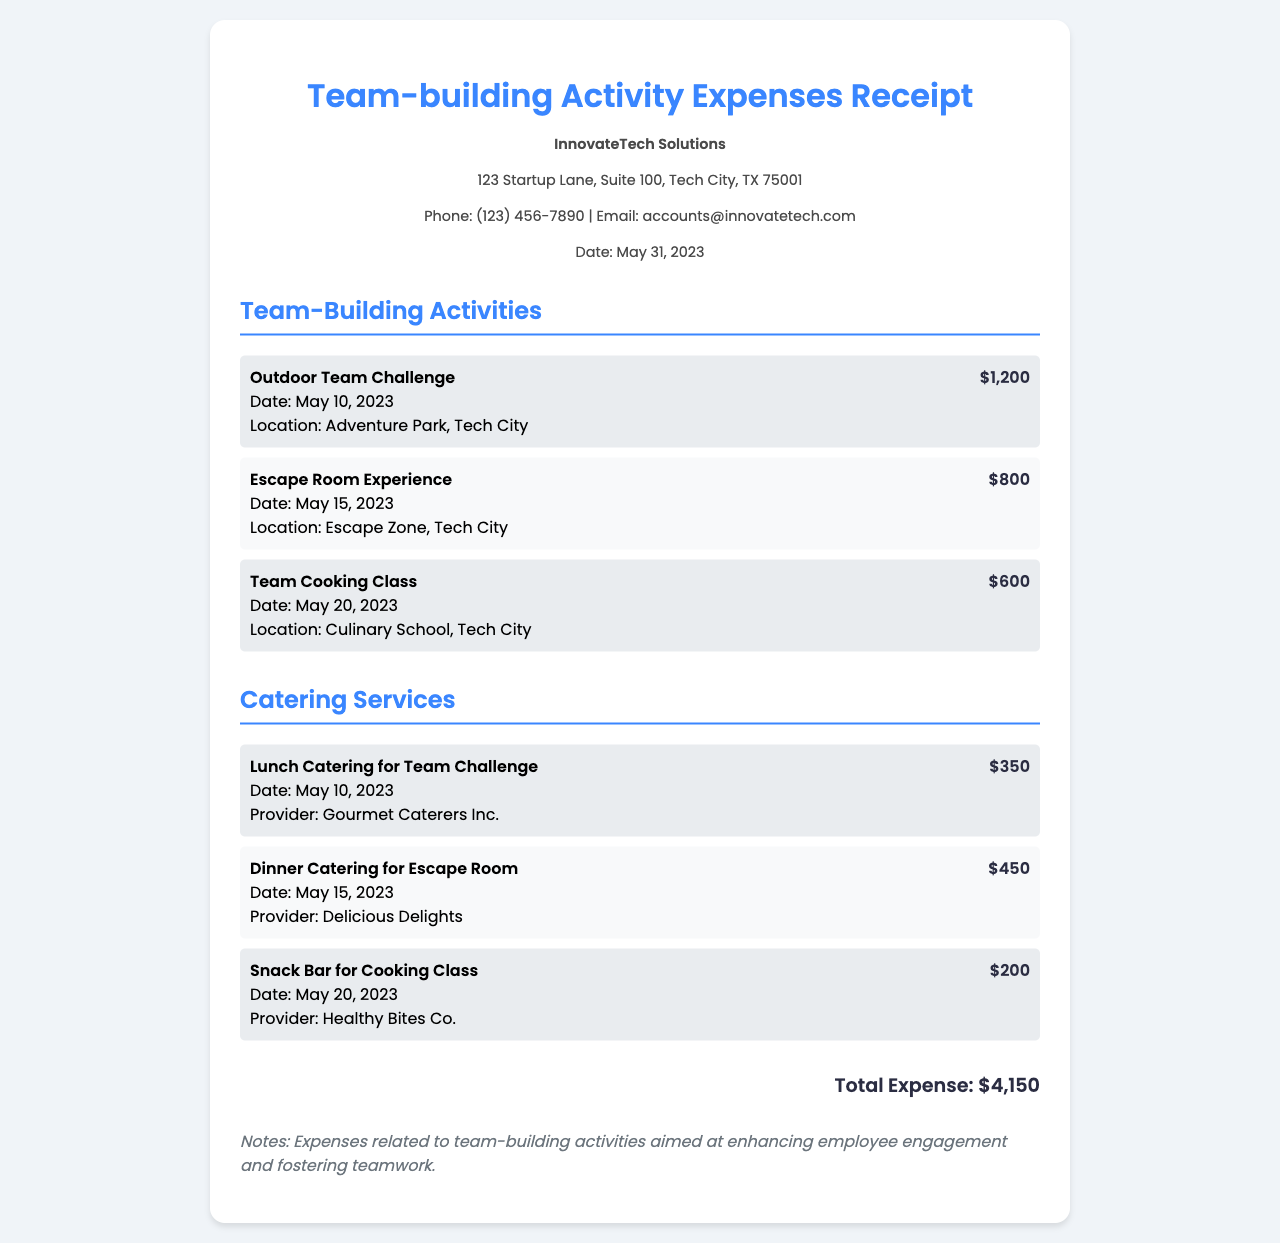What is the total expense? The total expense is listed at the bottom of the document as a sum of all activities and catering costs.
Answer: $4,150 What is the name of the company? The name of the company is stated at the top of the document.
Answer: InnovateTech Solutions When was the Outdoor Team Challenge held? The date for the Outdoor Team Challenge is specified in the expense category for team-building activities.
Answer: May 10, 2023 How much did the Escape Room Experience cost? The cost for the Escape Room Experience is detailed in the expense item listing.
Answer: $800 Who is the provider for the lunch catering? The provider for lunch catering is mentioned in the relevant catering services item.
Answer: Gourmet Caterers Inc What type of activity was held on May 20, 2023? The document states the specific activity associated with that date in the team-building activities section.
Answer: Team Cooking Class How many team-building activities are listed in total? The total number of team-building activities is summed from the individual items listed in the document.
Answer: 3 What is the date of the receipt? The date of the receipt is mentioned in the company info section at the top of the document.
Answer: May 31, 2023 Which activity had the highest cost? The most expensive activity can be deduced by comparing all listed costs in the team-building activities section.
Answer: Outdoor Team Challenge 